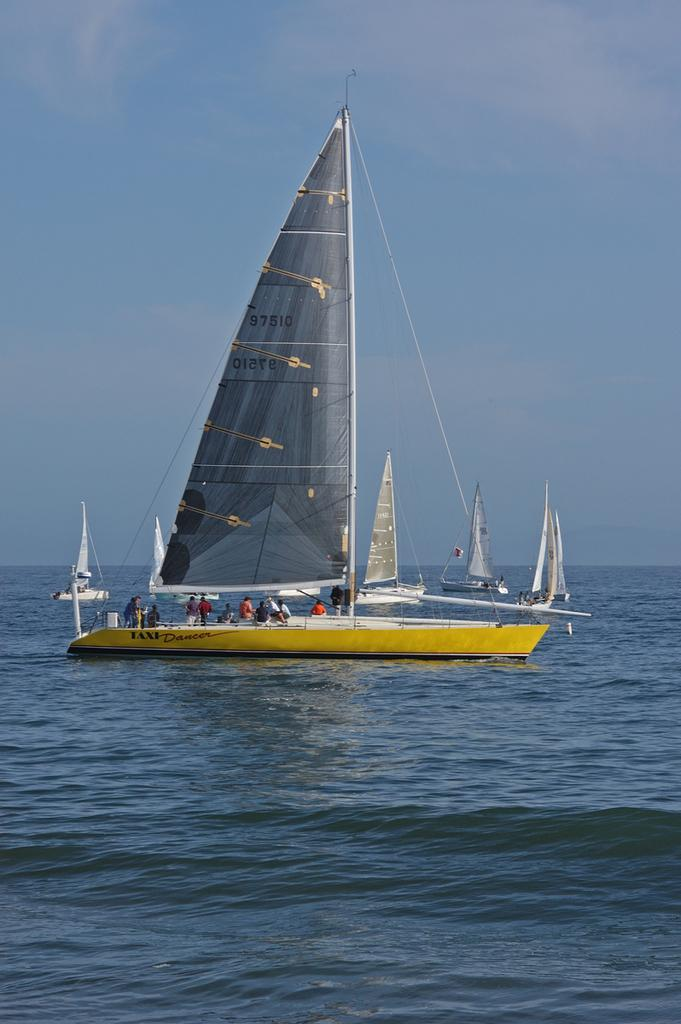What is the position of the boats in the image? The boats are above the water in the image. Are there any people present in the boats? Yes, there are people in the boat. What can be seen in the background of the image? The sky is visible in the background of the image. What type of apparel are the boats wearing in the image? Boats do not wear apparel; the question is not applicable to the image. Can you provide a detailed description of the boats' design in the image? The provided facts do not include a detailed description of the boats' design, so it cannot be answered definitively. 